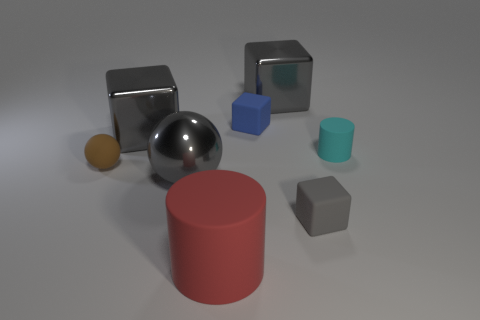Can you tell me what materials the objects appear to be made of? Certainly! In the image, the objects seem to be made of various materials. The two cubes on the left and the sphere appear to be made of a reflective metal, suggesting a polished surface. The blue cube seems to have a matte finish, possibly plastic. The teal cylinder has a more matte and slightly textured look, indicative of rubber or a soft plastic. Lastly, the red cylinder and gray cube have a similar matte texture to the teal cylinder, suggesting they may be made of a rubbery material as well. 